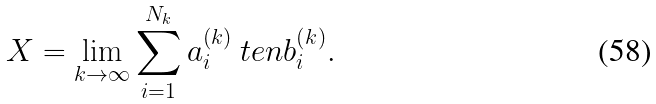<formula> <loc_0><loc_0><loc_500><loc_500>X = \lim _ { k \to \infty } \sum _ { i = 1 } ^ { N _ { k } } a _ { i } ^ { ( k ) } \ t e n b _ { i } ^ { ( k ) } .</formula> 